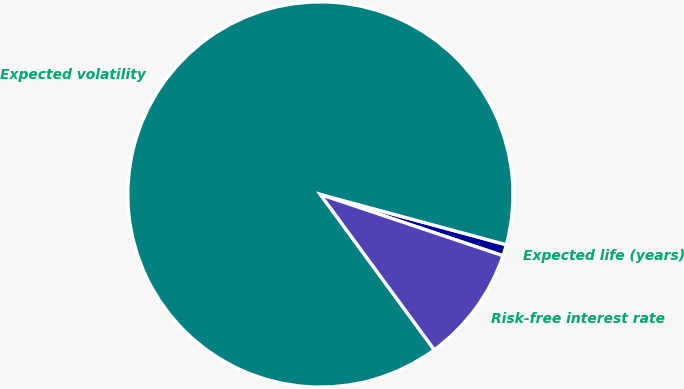Convert chart to OTSL. <chart><loc_0><loc_0><loc_500><loc_500><pie_chart><fcel>Expected life (years)<fcel>Expected volatility<fcel>Risk-free interest rate<nl><fcel>0.95%<fcel>89.26%<fcel>9.78%<nl></chart> 